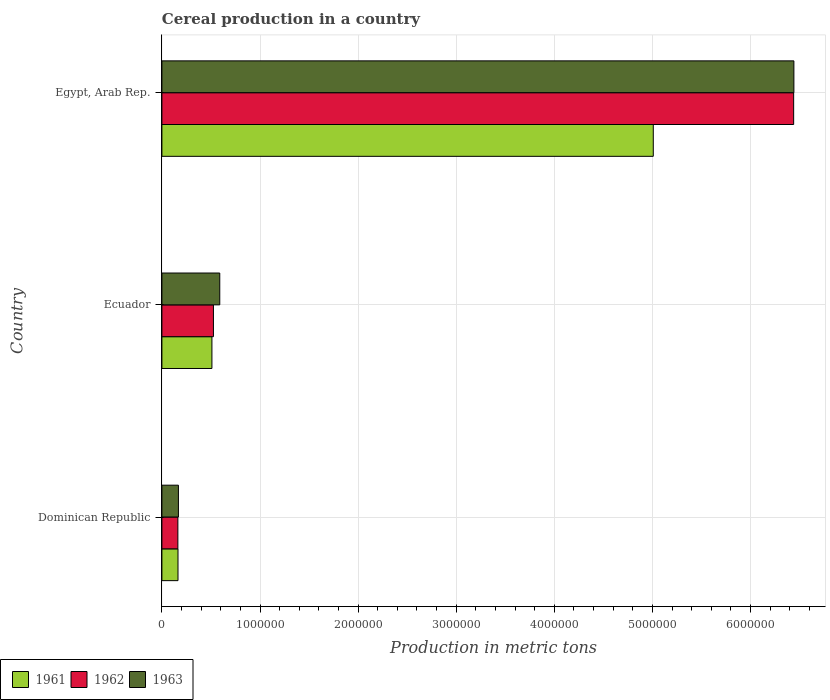How many different coloured bars are there?
Ensure brevity in your answer.  3. How many groups of bars are there?
Offer a very short reply. 3. Are the number of bars per tick equal to the number of legend labels?
Offer a very short reply. Yes. What is the label of the 3rd group of bars from the top?
Provide a short and direct response. Dominican Republic. In how many cases, is the number of bars for a given country not equal to the number of legend labels?
Offer a very short reply. 0. What is the total cereal production in 1962 in Dominican Republic?
Give a very brief answer. 1.63e+05. Across all countries, what is the maximum total cereal production in 1962?
Your response must be concise. 6.44e+06. Across all countries, what is the minimum total cereal production in 1962?
Provide a short and direct response. 1.63e+05. In which country was the total cereal production in 1961 maximum?
Keep it short and to the point. Egypt, Arab Rep. In which country was the total cereal production in 1961 minimum?
Ensure brevity in your answer.  Dominican Republic. What is the total total cereal production in 1962 in the graph?
Your answer should be very brief. 7.13e+06. What is the difference between the total cereal production in 1962 in Ecuador and that in Egypt, Arab Rep.?
Your response must be concise. -5.91e+06. What is the difference between the total cereal production in 1962 in Egypt, Arab Rep. and the total cereal production in 1961 in Dominican Republic?
Offer a very short reply. 6.28e+06. What is the average total cereal production in 1963 per country?
Give a very brief answer. 2.40e+06. What is the difference between the total cereal production in 1962 and total cereal production in 1963 in Egypt, Arab Rep.?
Offer a terse response. -2429. What is the ratio of the total cereal production in 1962 in Dominican Republic to that in Egypt, Arab Rep.?
Provide a succinct answer. 0.03. Is the total cereal production in 1963 in Ecuador less than that in Egypt, Arab Rep.?
Your answer should be very brief. Yes. Is the difference between the total cereal production in 1962 in Dominican Republic and Egypt, Arab Rep. greater than the difference between the total cereal production in 1963 in Dominican Republic and Egypt, Arab Rep.?
Ensure brevity in your answer.  No. What is the difference between the highest and the second highest total cereal production in 1962?
Make the answer very short. 5.91e+06. What is the difference between the highest and the lowest total cereal production in 1962?
Your answer should be compact. 6.28e+06. What does the 1st bar from the top in Egypt, Arab Rep. represents?
Give a very brief answer. 1963. What does the 3rd bar from the bottom in Ecuador represents?
Provide a short and direct response. 1963. Is it the case that in every country, the sum of the total cereal production in 1962 and total cereal production in 1961 is greater than the total cereal production in 1963?
Your answer should be very brief. Yes. How many bars are there?
Keep it short and to the point. 9. Are all the bars in the graph horizontal?
Give a very brief answer. Yes. How many countries are there in the graph?
Your response must be concise. 3. Are the values on the major ticks of X-axis written in scientific E-notation?
Your response must be concise. No. Does the graph contain any zero values?
Provide a short and direct response. No. Where does the legend appear in the graph?
Your answer should be very brief. Bottom left. How many legend labels are there?
Ensure brevity in your answer.  3. How are the legend labels stacked?
Your response must be concise. Horizontal. What is the title of the graph?
Provide a short and direct response. Cereal production in a country. What is the label or title of the X-axis?
Provide a short and direct response. Production in metric tons. What is the Production in metric tons of 1961 in Dominican Republic?
Give a very brief answer. 1.64e+05. What is the Production in metric tons in 1962 in Dominican Republic?
Your answer should be compact. 1.63e+05. What is the Production in metric tons of 1963 in Dominican Republic?
Give a very brief answer. 1.68e+05. What is the Production in metric tons of 1961 in Ecuador?
Give a very brief answer. 5.10e+05. What is the Production in metric tons in 1962 in Ecuador?
Make the answer very short. 5.25e+05. What is the Production in metric tons of 1963 in Ecuador?
Offer a terse response. 5.90e+05. What is the Production in metric tons of 1961 in Egypt, Arab Rep.?
Provide a succinct answer. 5.01e+06. What is the Production in metric tons in 1962 in Egypt, Arab Rep.?
Your answer should be compact. 6.44e+06. What is the Production in metric tons of 1963 in Egypt, Arab Rep.?
Your response must be concise. 6.44e+06. Across all countries, what is the maximum Production in metric tons of 1961?
Keep it short and to the point. 5.01e+06. Across all countries, what is the maximum Production in metric tons in 1962?
Offer a terse response. 6.44e+06. Across all countries, what is the maximum Production in metric tons of 1963?
Your response must be concise. 6.44e+06. Across all countries, what is the minimum Production in metric tons in 1961?
Offer a terse response. 1.64e+05. Across all countries, what is the minimum Production in metric tons in 1962?
Provide a short and direct response. 1.63e+05. Across all countries, what is the minimum Production in metric tons of 1963?
Your answer should be compact. 1.68e+05. What is the total Production in metric tons in 1961 in the graph?
Offer a very short reply. 5.68e+06. What is the total Production in metric tons in 1962 in the graph?
Provide a short and direct response. 7.13e+06. What is the total Production in metric tons of 1963 in the graph?
Give a very brief answer. 7.20e+06. What is the difference between the Production in metric tons in 1961 in Dominican Republic and that in Ecuador?
Make the answer very short. -3.46e+05. What is the difference between the Production in metric tons of 1962 in Dominican Republic and that in Ecuador?
Make the answer very short. -3.63e+05. What is the difference between the Production in metric tons in 1963 in Dominican Republic and that in Ecuador?
Offer a very short reply. -4.22e+05. What is the difference between the Production in metric tons in 1961 in Dominican Republic and that in Egypt, Arab Rep.?
Ensure brevity in your answer.  -4.84e+06. What is the difference between the Production in metric tons of 1962 in Dominican Republic and that in Egypt, Arab Rep.?
Your response must be concise. -6.28e+06. What is the difference between the Production in metric tons of 1963 in Dominican Republic and that in Egypt, Arab Rep.?
Keep it short and to the point. -6.27e+06. What is the difference between the Production in metric tons in 1961 in Ecuador and that in Egypt, Arab Rep.?
Provide a succinct answer. -4.50e+06. What is the difference between the Production in metric tons of 1962 in Ecuador and that in Egypt, Arab Rep.?
Offer a terse response. -5.91e+06. What is the difference between the Production in metric tons of 1963 in Ecuador and that in Egypt, Arab Rep.?
Keep it short and to the point. -5.85e+06. What is the difference between the Production in metric tons of 1961 in Dominican Republic and the Production in metric tons of 1962 in Ecuador?
Your response must be concise. -3.61e+05. What is the difference between the Production in metric tons of 1961 in Dominican Republic and the Production in metric tons of 1963 in Ecuador?
Provide a succinct answer. -4.26e+05. What is the difference between the Production in metric tons in 1962 in Dominican Republic and the Production in metric tons in 1963 in Ecuador?
Your response must be concise. -4.27e+05. What is the difference between the Production in metric tons in 1961 in Dominican Republic and the Production in metric tons in 1962 in Egypt, Arab Rep.?
Offer a terse response. -6.28e+06. What is the difference between the Production in metric tons of 1961 in Dominican Republic and the Production in metric tons of 1963 in Egypt, Arab Rep.?
Provide a succinct answer. -6.28e+06. What is the difference between the Production in metric tons of 1962 in Dominican Republic and the Production in metric tons of 1963 in Egypt, Arab Rep.?
Keep it short and to the point. -6.28e+06. What is the difference between the Production in metric tons of 1961 in Ecuador and the Production in metric tons of 1962 in Egypt, Arab Rep.?
Offer a terse response. -5.93e+06. What is the difference between the Production in metric tons of 1961 in Ecuador and the Production in metric tons of 1963 in Egypt, Arab Rep.?
Provide a short and direct response. -5.93e+06. What is the difference between the Production in metric tons in 1962 in Ecuador and the Production in metric tons in 1963 in Egypt, Arab Rep.?
Your answer should be compact. -5.92e+06. What is the average Production in metric tons of 1961 per country?
Make the answer very short. 1.89e+06. What is the average Production in metric tons of 1962 per country?
Make the answer very short. 2.38e+06. What is the average Production in metric tons in 1963 per country?
Offer a terse response. 2.40e+06. What is the difference between the Production in metric tons of 1961 and Production in metric tons of 1962 in Dominican Republic?
Keep it short and to the point. 1325. What is the difference between the Production in metric tons of 1961 and Production in metric tons of 1963 in Dominican Republic?
Provide a succinct answer. -4343. What is the difference between the Production in metric tons of 1962 and Production in metric tons of 1963 in Dominican Republic?
Offer a terse response. -5668. What is the difference between the Production in metric tons of 1961 and Production in metric tons of 1962 in Ecuador?
Ensure brevity in your answer.  -1.55e+04. What is the difference between the Production in metric tons in 1961 and Production in metric tons in 1963 in Ecuador?
Provide a short and direct response. -8.00e+04. What is the difference between the Production in metric tons of 1962 and Production in metric tons of 1963 in Ecuador?
Keep it short and to the point. -6.45e+04. What is the difference between the Production in metric tons of 1961 and Production in metric tons of 1962 in Egypt, Arab Rep.?
Keep it short and to the point. -1.43e+06. What is the difference between the Production in metric tons in 1961 and Production in metric tons in 1963 in Egypt, Arab Rep.?
Offer a very short reply. -1.43e+06. What is the difference between the Production in metric tons in 1962 and Production in metric tons in 1963 in Egypt, Arab Rep.?
Ensure brevity in your answer.  -2429. What is the ratio of the Production in metric tons in 1961 in Dominican Republic to that in Ecuador?
Keep it short and to the point. 0.32. What is the ratio of the Production in metric tons of 1962 in Dominican Republic to that in Ecuador?
Offer a terse response. 0.31. What is the ratio of the Production in metric tons of 1963 in Dominican Republic to that in Ecuador?
Ensure brevity in your answer.  0.29. What is the ratio of the Production in metric tons of 1961 in Dominican Republic to that in Egypt, Arab Rep.?
Provide a short and direct response. 0.03. What is the ratio of the Production in metric tons in 1962 in Dominican Republic to that in Egypt, Arab Rep.?
Ensure brevity in your answer.  0.03. What is the ratio of the Production in metric tons of 1963 in Dominican Republic to that in Egypt, Arab Rep.?
Your answer should be very brief. 0.03. What is the ratio of the Production in metric tons in 1961 in Ecuador to that in Egypt, Arab Rep.?
Your answer should be very brief. 0.1. What is the ratio of the Production in metric tons in 1962 in Ecuador to that in Egypt, Arab Rep.?
Offer a terse response. 0.08. What is the ratio of the Production in metric tons in 1963 in Ecuador to that in Egypt, Arab Rep.?
Keep it short and to the point. 0.09. What is the difference between the highest and the second highest Production in metric tons of 1961?
Provide a short and direct response. 4.50e+06. What is the difference between the highest and the second highest Production in metric tons of 1962?
Offer a terse response. 5.91e+06. What is the difference between the highest and the second highest Production in metric tons in 1963?
Your response must be concise. 5.85e+06. What is the difference between the highest and the lowest Production in metric tons of 1961?
Keep it short and to the point. 4.84e+06. What is the difference between the highest and the lowest Production in metric tons in 1962?
Your answer should be compact. 6.28e+06. What is the difference between the highest and the lowest Production in metric tons in 1963?
Provide a short and direct response. 6.27e+06. 